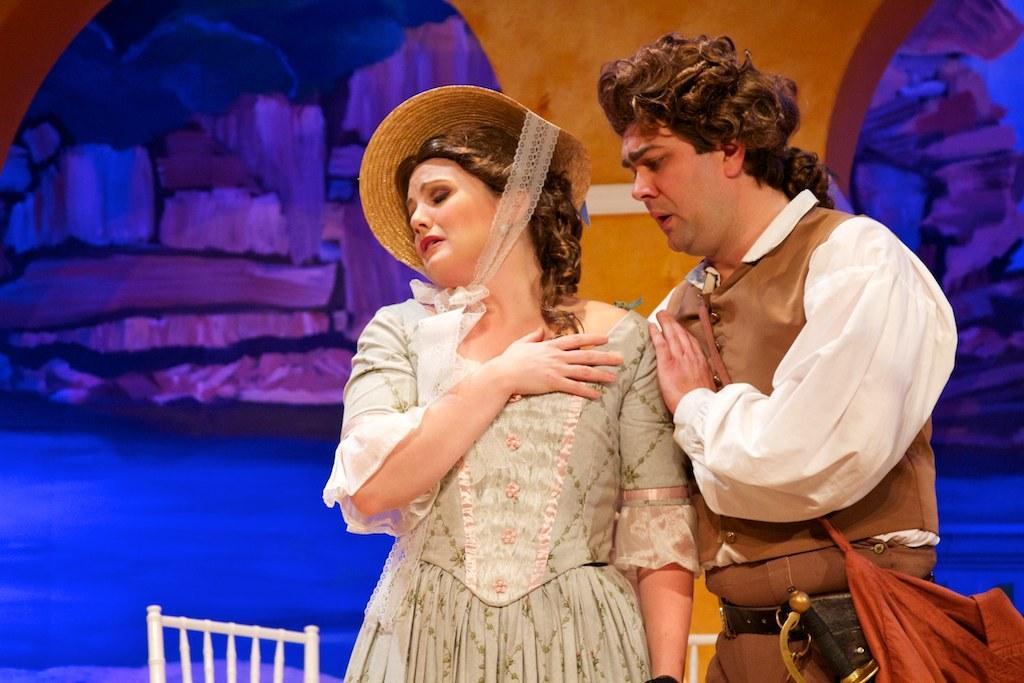How would you summarize this image in a sentence or two? In this image, we can see people and one of them is wearing a hat and the other is wearing a bag and a sword. In the background, we can see paintings on the wall and at the bottom, there are chairs. 